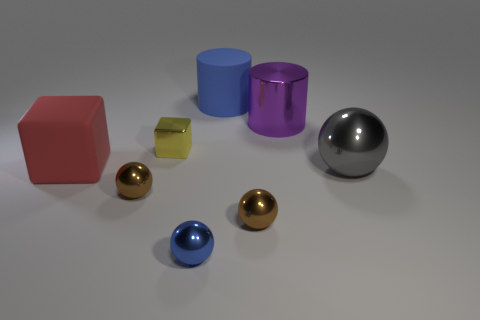Subtract 1 balls. How many balls are left? 3 Subtract all yellow cubes. Subtract all yellow cylinders. How many cubes are left? 1 Add 1 brown balls. How many objects exist? 9 Subtract all cylinders. How many objects are left? 6 Add 6 large brown objects. How many large brown objects exist? 6 Subtract 1 purple cylinders. How many objects are left? 7 Subtract all brown objects. Subtract all tiny things. How many objects are left? 2 Add 6 metal spheres. How many metal spheres are left? 10 